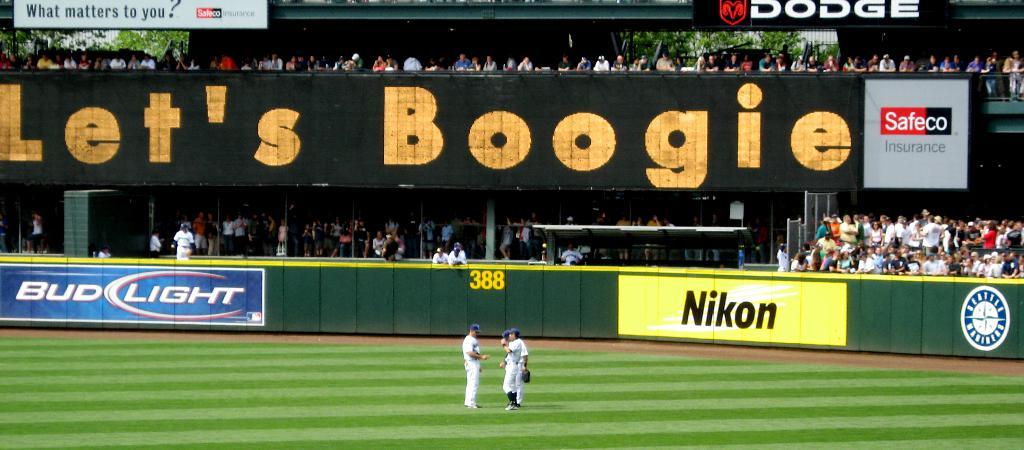Is nikon a sponsor?
Offer a terse response. Yes. What advert is on the wall?
Keep it short and to the point. Nikon. 